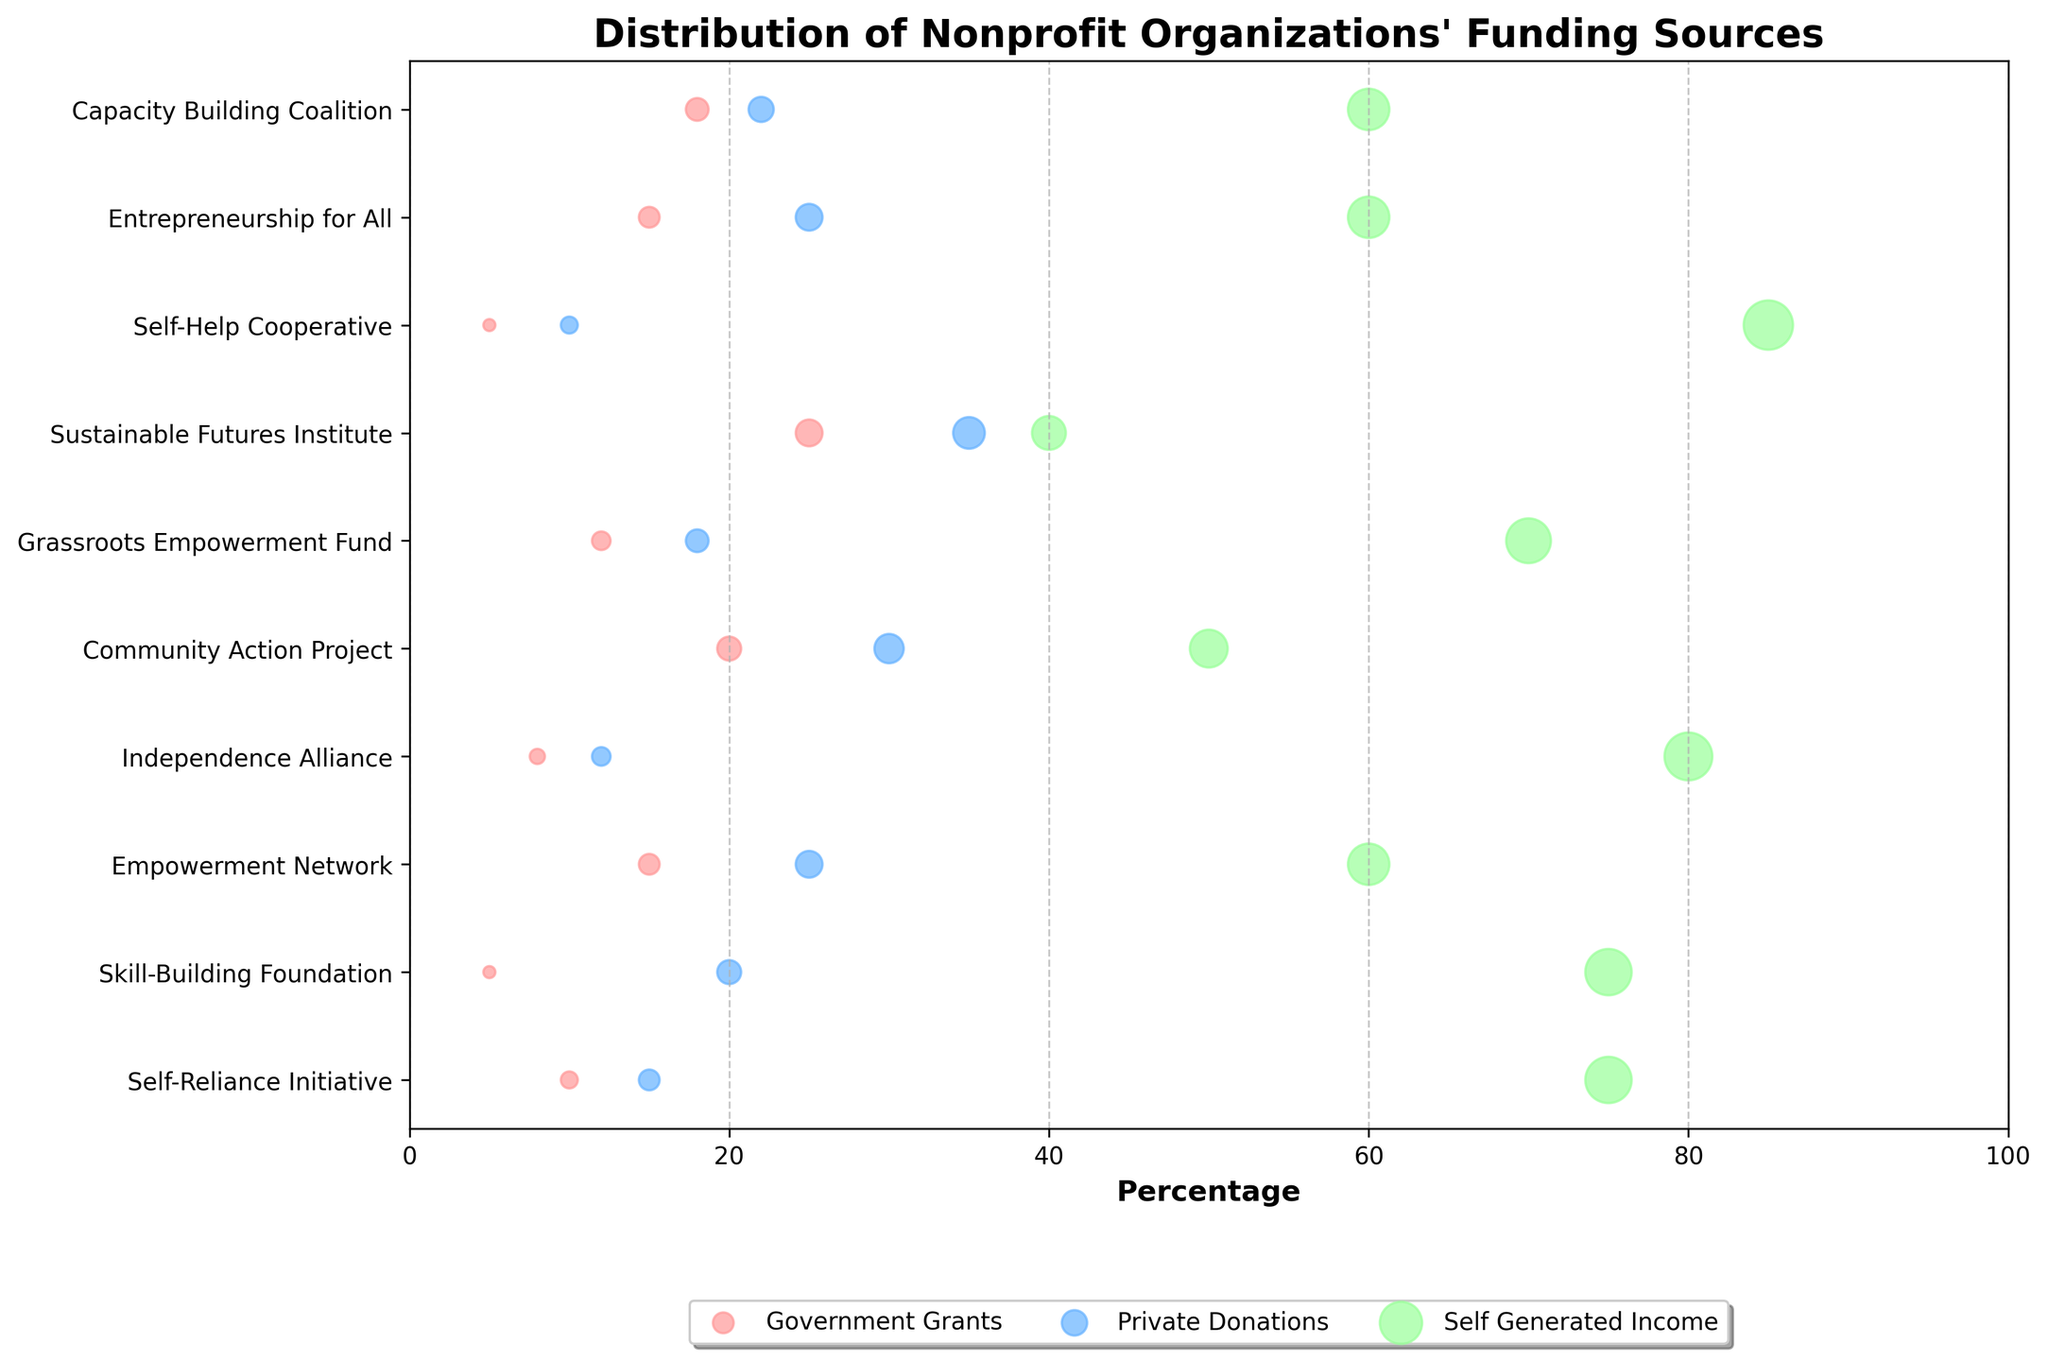What is the title of the figure? The title is usually located at the top of a figure. In this case, you should look for a bold text that describes what the figure is about.
Answer: Distribution of Nonprofit Organizations' Funding Sources Which organization has the highest percentage of self-generated income? Locate the green dots, which represent self-generated income, and identify the one that has the highest value on the x-axis. Then, check the corresponding organization on the y-axis.
Answer: Self-Help Cooperative What is the approximate average percentage of government grants among all organizations? Identify all the red dots that represent government grants, sum their x-axis values, and divide by the number of organizations (10).
Answer: Approx. 13.3% Which organizations receive more government grants than private donations? Compare the red (government grants) and blue (private donations) dots for each organization and identify the organizations where the red dots are further to the right than the blue dots.
Answer: Community Action Project, Sustainable Futures Institute What is the range of percentages for private donations? Identify the highest and lowest values of the blue dots (private donations) on the x-axis. The range is the difference between these values.
Answer: 10% to 35% Which organization has the most balanced funding sources in terms of percentages? Look for the organization where the three dots (red, blue, and green) are closest to each other on the x-axis.
Answer: Empowerment Network How much more does the Capacity Building Coalition receive from private donations compared to government grants? Read the x-axis values for both private donations (blue dot) and government grants (red dot) for the Capacity Building Coalition, then subtract the government grants value from the private donations value.
Answer: 4% Which organizations receive at least 60% of their funding from self-generated income? Identify the green dots representing self-generated income that are 60% or higher on the x-axis, then check the corresponding organizations on the y-axis.
Answer: Self-Reliance Initiative, Skill-Building Foundation, Empowerment Network, Independence Alliance, Grassroots Empowerment Fund, Self-Help Cooperative, Entrepreneurship for All, Capacity Building Coalition Are there any organizations that do not receive at least 10% from government grants? Identify red dots on the x-axis that are below 10%, and then check the corresponding organizations on the y-axis.
Answer: Skill-Building Foundation, Self-Help Cooperative How does the Empowerment Network's funding distribution compare to the Sustainable Futures Institute? Compare the x-axis values for government grants, private donations, and self-generated income for both organizations, noting the differences.
Answer: Empowerment Network has lower government grants, lower private donations, and higher self-generated income compared to Sustainable Futures Institute 